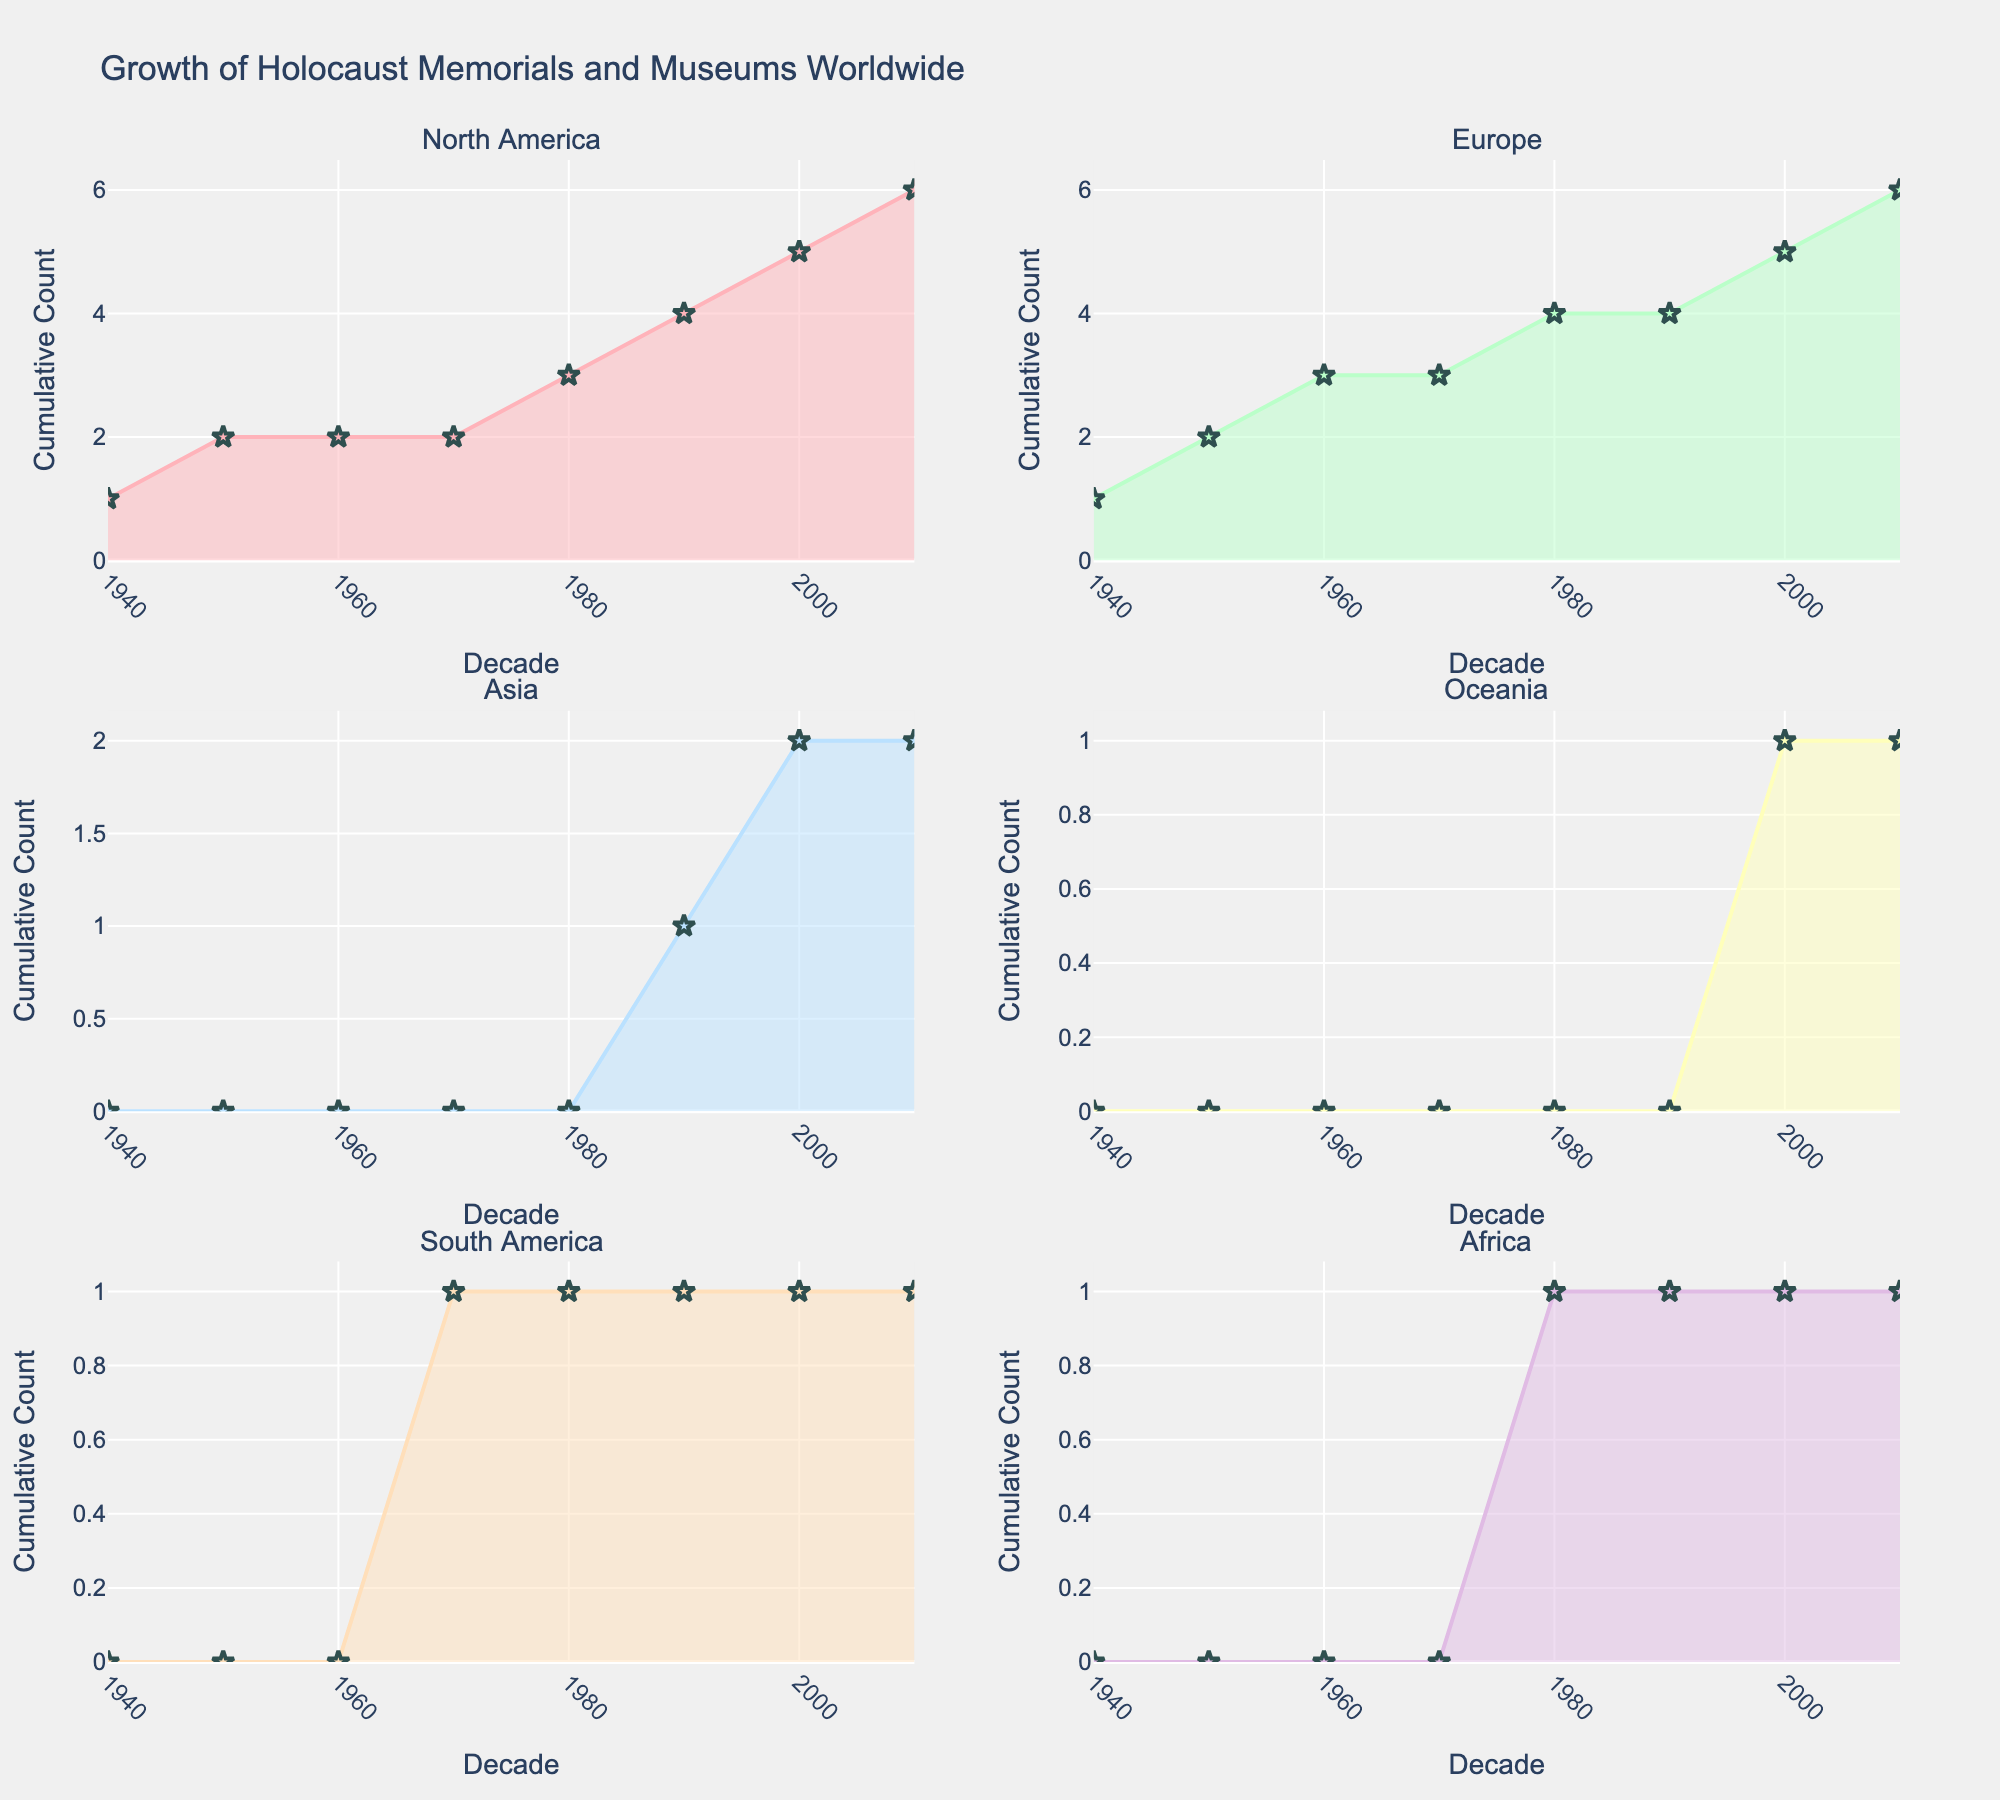What is the title of the figure? The title is usually displayed at the top of the figure. In this case, it reads "Growth of Holocaust Memorials and Museums Worldwide."
Answer: Growth of Holocaust Memorials and Museums Worldwide How many subplots are there in the figure? By observing the overall structure, you can see that there are 3 rows and 2 columns of subplots.
Answer: 6 Which continent has the earliest decade represented in the subplots? By examining each subplot, you notice that North America and Europe both have data starting in the 1940s.
Answer: North America and Europe What is the y-axis title in each subplot? Observing any subplot, the y-axis is labeled clearly. In all subplots, it reads "Cumulative Count."
Answer: Cumulative Count Which continent has the highest cumulative count by the 2010s? By looking at the highest points in each subplot for the 2010s, North America's subplot shows the highest cumulative count compared to the others.
Answer: North America During which decade did Europe see the most significant growth in the number of memorials and museums? By looking at the slope of the area chart in the Europe subplot, it appears that the 2000s saw a significant upward slope, indicating the most substantial growth.
Answer: 2000s How does the cumulative count of memorials and museums in Asia in the 2000s compare to that in North America in the same decade? Comparing the heights of the 2000s data points between Asia and North America subplots, it’s clear North America has a higher cumulative count.
Answer: North America has a higher cumulative count Which continent had no new memorials or museums after the 1990s? By examining each subplot, Oceania shows no additional rise after the 2000s, so no new additions are apparent post-1990s.
Answer: Oceania 